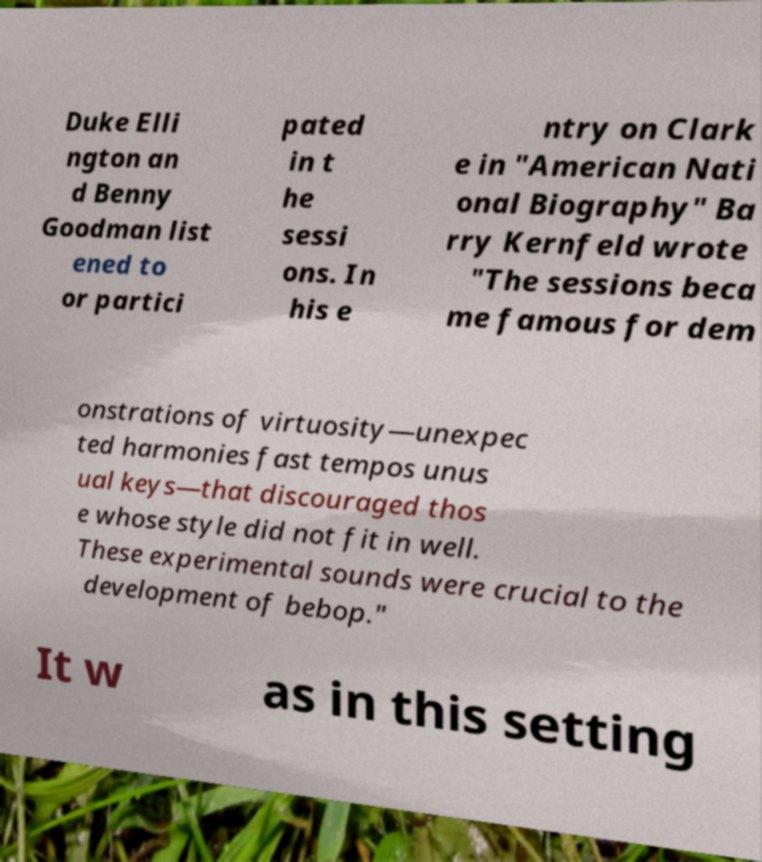What messages or text are displayed in this image? I need them in a readable, typed format. Duke Elli ngton an d Benny Goodman list ened to or partici pated in t he sessi ons. In his e ntry on Clark e in "American Nati onal Biography" Ba rry Kernfeld wrote "The sessions beca me famous for dem onstrations of virtuosity—unexpec ted harmonies fast tempos unus ual keys—that discouraged thos e whose style did not fit in well. These experimental sounds were crucial to the development of bebop." It w as in this setting 